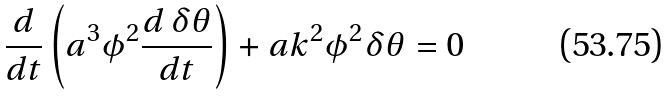Convert formula to latex. <formula><loc_0><loc_0><loc_500><loc_500>\frac { d } { d t } \left ( a ^ { 3 } \phi ^ { 2 } \frac { d \, \delta \theta } { d t } \right ) + a k ^ { 2 } \phi ^ { 2 } \delta \theta = 0</formula> 